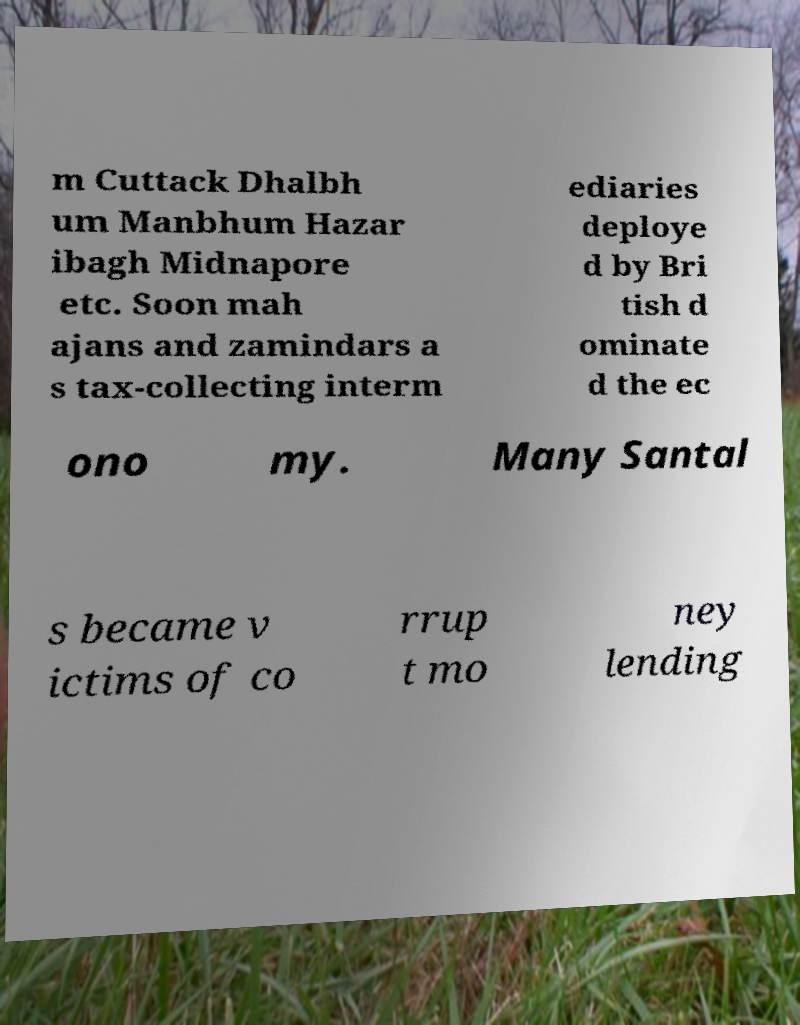Could you extract and type out the text from this image? m Cuttack Dhalbh um Manbhum Hazar ibagh Midnapore etc. Soon mah ajans and zamindars a s tax-collecting interm ediaries deploye d by Bri tish d ominate d the ec ono my. Many Santal s became v ictims of co rrup t mo ney lending 